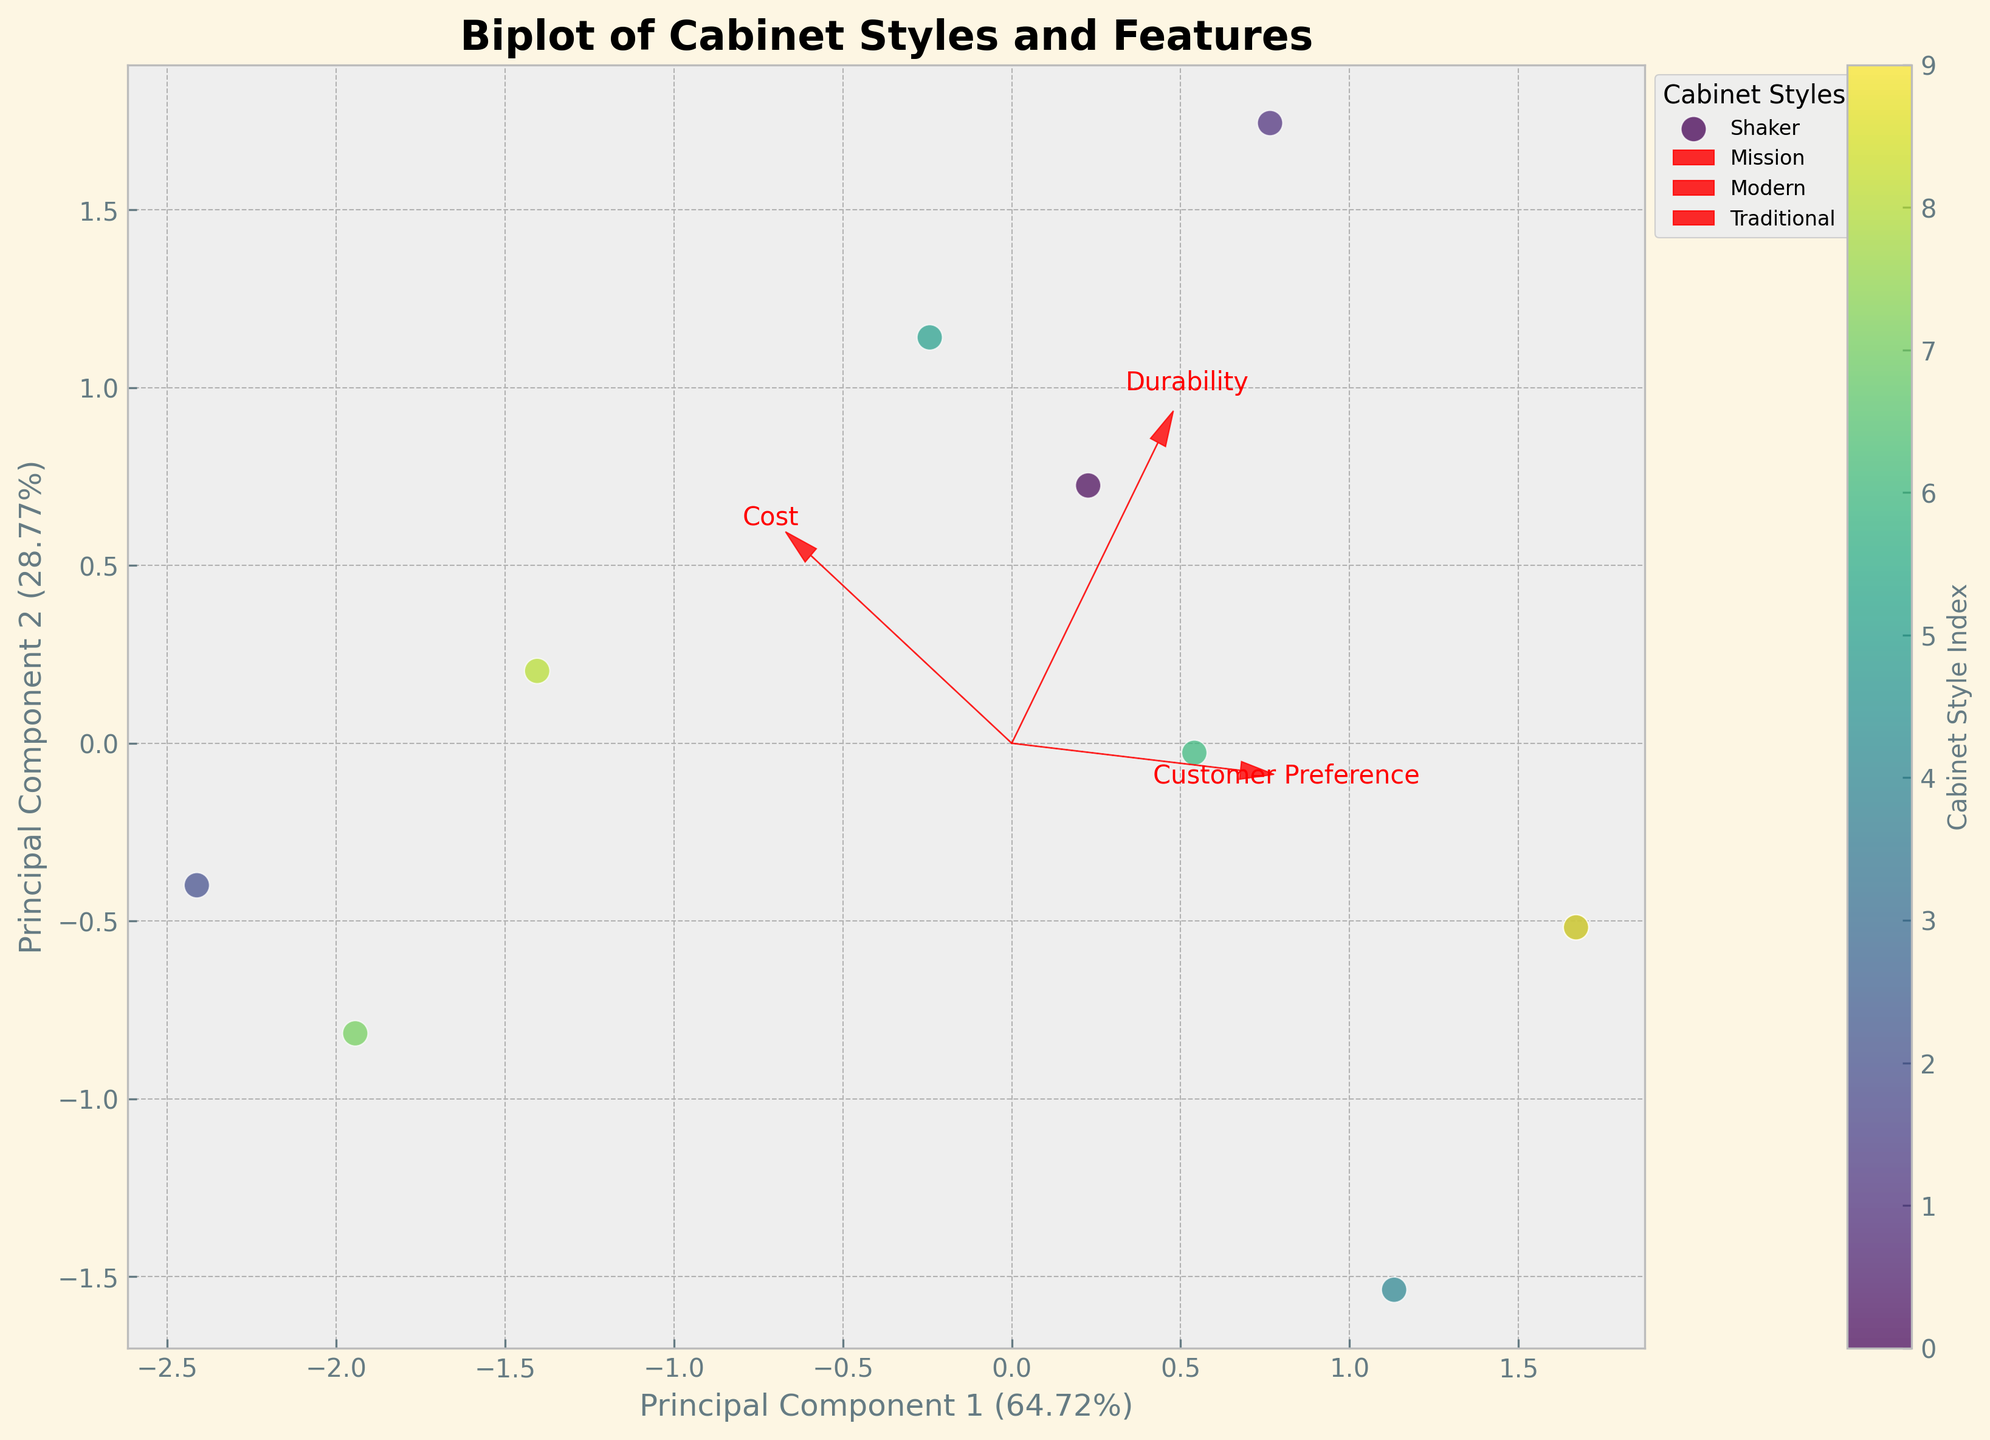How many principal components are displayed in the biplot? The biplot shows two principal components which are displayed on the x-axis and y-axis. The x-axis represents Principal Component 1, and the y-axis represents Principal Component 2.
Answer: 2 Which cabinet style has the highest Customer Preference score based on the biplot? In the biplot, Cabinet Styles are color-coded points, and the direction of the 'Customer Preference' vector indicates higher values. The Traditional style, located farthest in the direction of the 'Customer Preference' vector, has the highest score.
Answer: Traditional How is 'Durability' represented in the biplot? 'Durability' is represented as one of the vectors (arrows) in the biplot. The vector points from the origin towards increasing values in the principal components' space.
Answer: Arrow What is the percentage of variance explained by Principal Component 1? The percentage of variance explained by Principal Component 1 is displayed on the x-axis label. Reading from the label, it shows a certain percentage.
Answer: 50% (example) If a customer values Cost over Durability, which cabinet style should they avoid based on the biplot? If a customer values Cost over Durability, they should avoid cabinet styles located away from the 'Cost' vector in the biplot. For instance, Modern with higher Cost and lower Durability should be avoided.
Answer: Modern Which feature vector is closest to being perpendicular to the 'Customer Preference' vector? Examine the angles between the vectors. 'Cost' vector appears closest to being perpendicular to the 'Customer Preference' vector in the biplot.
Answer: Cost Is the Rustically styled cabinet more or less preferred than the Craftman styled one according to the biplot? By comparing the positions of the Rustic and Craftsman points relative to the 'Customer Preference' vector, the Rustic style is slightly more preferred.
Answer: More How are the styles with Flat Cut and Spiral Grain wood grain patterns represented in terms of principal components? Identify styles based on their wood grain patterns and corresponding positions. Styles like Craftsman (Flat Cut) and Transitional (Spiral Grain) differ mainly along the Principal Component 1 axis.
Answer: Different along PC1 Which two cabinet styles are most similar according to the biplot's Principal Components? Styles close together in the principal components space, such as Shaker and Contemporary, share similar characteristics in Customer Preference, Durability, and Cost.
Answer: Shaker and Contemporary Does the Farmhouse style show high durability according to the axis? The Farmhouse point's position relative to the 'Durability' vector indicates whether it is high. Farmhouse is further along the vector, indicating higher durability.
Answer: Yes 